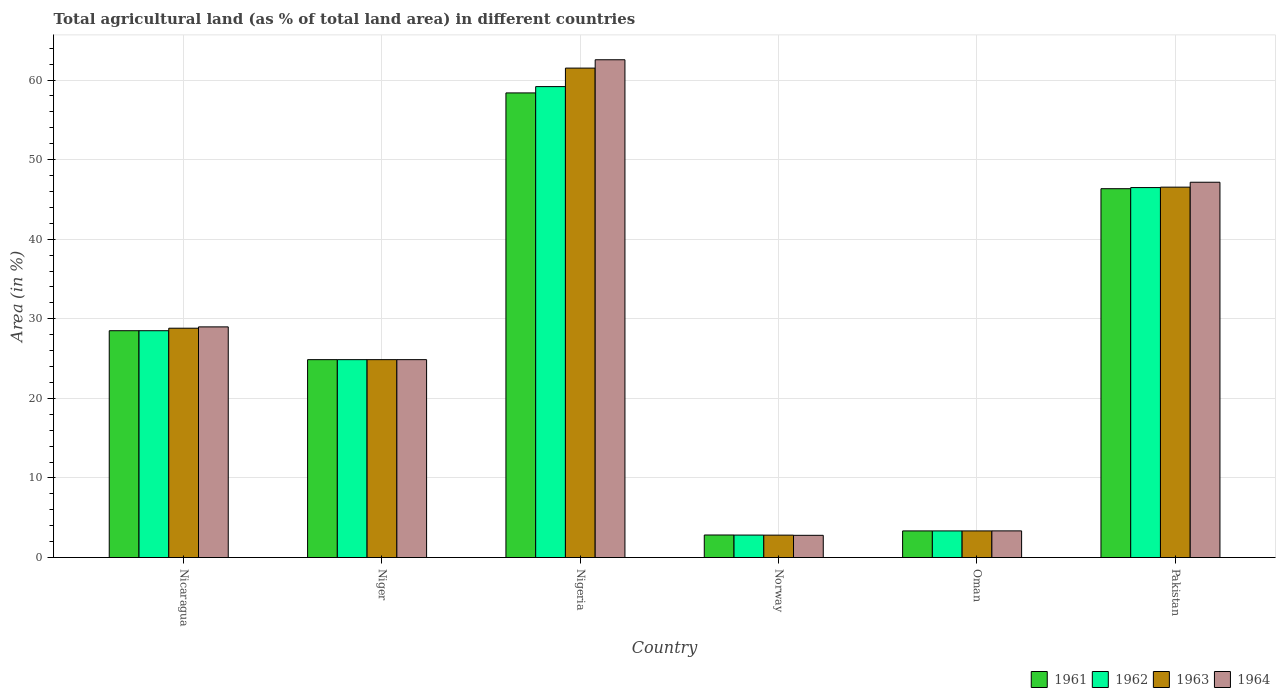How many different coloured bars are there?
Your response must be concise. 4. How many groups of bars are there?
Ensure brevity in your answer.  6. Are the number of bars per tick equal to the number of legend labels?
Your answer should be very brief. Yes. What is the label of the 5th group of bars from the left?
Your answer should be compact. Oman. In how many cases, is the number of bars for a given country not equal to the number of legend labels?
Provide a succinct answer. 0. What is the percentage of agricultural land in 1961 in Niger?
Make the answer very short. 24.87. Across all countries, what is the maximum percentage of agricultural land in 1963?
Give a very brief answer. 61.51. Across all countries, what is the minimum percentage of agricultural land in 1963?
Your answer should be very brief. 2.81. In which country was the percentage of agricultural land in 1963 maximum?
Give a very brief answer. Nigeria. What is the total percentage of agricultural land in 1963 in the graph?
Make the answer very short. 167.89. What is the difference between the percentage of agricultural land in 1962 in Nicaragua and that in Nigeria?
Make the answer very short. -30.68. What is the difference between the percentage of agricultural land in 1964 in Nigeria and the percentage of agricultural land in 1961 in Norway?
Ensure brevity in your answer.  59.72. What is the average percentage of agricultural land in 1962 per country?
Ensure brevity in your answer.  27.54. What is the difference between the percentage of agricultural land of/in 1964 and percentage of agricultural land of/in 1962 in Nicaragua?
Offer a terse response. 0.48. In how many countries, is the percentage of agricultural land in 1963 greater than 24 %?
Your response must be concise. 4. What is the ratio of the percentage of agricultural land in 1963 in Nicaragua to that in Nigeria?
Provide a short and direct response. 0.47. Is the percentage of agricultural land in 1964 in Norway less than that in Pakistan?
Your answer should be compact. Yes. What is the difference between the highest and the second highest percentage of agricultural land in 1963?
Your response must be concise. -32.69. What is the difference between the highest and the lowest percentage of agricultural land in 1963?
Your answer should be compact. 58.69. In how many countries, is the percentage of agricultural land in 1961 greater than the average percentage of agricultural land in 1961 taken over all countries?
Keep it short and to the point. 3. What does the 4th bar from the left in Oman represents?
Ensure brevity in your answer.  1964. Is it the case that in every country, the sum of the percentage of agricultural land in 1962 and percentage of agricultural land in 1961 is greater than the percentage of agricultural land in 1964?
Provide a short and direct response. Yes. How many countries are there in the graph?
Ensure brevity in your answer.  6. Are the values on the major ticks of Y-axis written in scientific E-notation?
Your answer should be compact. No. Does the graph contain any zero values?
Give a very brief answer. No. How many legend labels are there?
Your answer should be very brief. 4. What is the title of the graph?
Your response must be concise. Total agricultural land (as % of total land area) in different countries. What is the label or title of the Y-axis?
Your answer should be very brief. Area (in %). What is the Area (in %) in 1961 in Nicaragua?
Offer a very short reply. 28.5. What is the Area (in %) in 1962 in Nicaragua?
Provide a succinct answer. 28.5. What is the Area (in %) of 1963 in Nicaragua?
Your answer should be compact. 28.82. What is the Area (in %) in 1964 in Nicaragua?
Provide a short and direct response. 28.98. What is the Area (in %) of 1961 in Niger?
Offer a terse response. 24.87. What is the Area (in %) of 1962 in Niger?
Offer a very short reply. 24.87. What is the Area (in %) in 1963 in Niger?
Keep it short and to the point. 24.87. What is the Area (in %) of 1964 in Niger?
Offer a terse response. 24.87. What is the Area (in %) in 1961 in Nigeria?
Provide a succinct answer. 58.39. What is the Area (in %) in 1962 in Nigeria?
Make the answer very short. 59.18. What is the Area (in %) of 1963 in Nigeria?
Your response must be concise. 61.51. What is the Area (in %) of 1964 in Nigeria?
Offer a very short reply. 62.55. What is the Area (in %) of 1961 in Norway?
Make the answer very short. 2.83. What is the Area (in %) in 1962 in Norway?
Your answer should be compact. 2.82. What is the Area (in %) of 1963 in Norway?
Provide a succinct answer. 2.81. What is the Area (in %) of 1964 in Norway?
Provide a succinct answer. 2.79. What is the Area (in %) in 1961 in Oman?
Your response must be concise. 3.34. What is the Area (in %) of 1962 in Oman?
Ensure brevity in your answer.  3.34. What is the Area (in %) of 1963 in Oman?
Give a very brief answer. 3.34. What is the Area (in %) in 1964 in Oman?
Your answer should be very brief. 3.35. What is the Area (in %) in 1961 in Pakistan?
Provide a short and direct response. 46.35. What is the Area (in %) of 1962 in Pakistan?
Ensure brevity in your answer.  46.49. What is the Area (in %) of 1963 in Pakistan?
Keep it short and to the point. 46.54. What is the Area (in %) of 1964 in Pakistan?
Make the answer very short. 47.16. Across all countries, what is the maximum Area (in %) in 1961?
Offer a terse response. 58.39. Across all countries, what is the maximum Area (in %) of 1962?
Give a very brief answer. 59.18. Across all countries, what is the maximum Area (in %) in 1963?
Provide a succinct answer. 61.51. Across all countries, what is the maximum Area (in %) in 1964?
Your response must be concise. 62.55. Across all countries, what is the minimum Area (in %) in 1961?
Keep it short and to the point. 2.83. Across all countries, what is the minimum Area (in %) of 1962?
Your response must be concise. 2.82. Across all countries, what is the minimum Area (in %) in 1963?
Give a very brief answer. 2.81. Across all countries, what is the minimum Area (in %) of 1964?
Give a very brief answer. 2.79. What is the total Area (in %) in 1961 in the graph?
Your answer should be very brief. 164.28. What is the total Area (in %) in 1962 in the graph?
Provide a short and direct response. 165.21. What is the total Area (in %) of 1963 in the graph?
Your response must be concise. 167.89. What is the total Area (in %) of 1964 in the graph?
Your response must be concise. 169.7. What is the difference between the Area (in %) in 1961 in Nicaragua and that in Niger?
Provide a short and direct response. 3.63. What is the difference between the Area (in %) of 1962 in Nicaragua and that in Niger?
Keep it short and to the point. 3.63. What is the difference between the Area (in %) of 1963 in Nicaragua and that in Niger?
Your answer should be compact. 3.95. What is the difference between the Area (in %) in 1964 in Nicaragua and that in Niger?
Keep it short and to the point. 4.12. What is the difference between the Area (in %) of 1961 in Nicaragua and that in Nigeria?
Provide a short and direct response. -29.88. What is the difference between the Area (in %) in 1962 in Nicaragua and that in Nigeria?
Provide a short and direct response. -30.68. What is the difference between the Area (in %) in 1963 in Nicaragua and that in Nigeria?
Offer a very short reply. -32.69. What is the difference between the Area (in %) of 1964 in Nicaragua and that in Nigeria?
Make the answer very short. -33.57. What is the difference between the Area (in %) in 1961 in Nicaragua and that in Norway?
Ensure brevity in your answer.  25.67. What is the difference between the Area (in %) in 1962 in Nicaragua and that in Norway?
Your answer should be very brief. 25.68. What is the difference between the Area (in %) in 1963 in Nicaragua and that in Norway?
Your response must be concise. 26. What is the difference between the Area (in %) in 1964 in Nicaragua and that in Norway?
Offer a terse response. 26.19. What is the difference between the Area (in %) of 1961 in Nicaragua and that in Oman?
Your answer should be very brief. 25.16. What is the difference between the Area (in %) in 1962 in Nicaragua and that in Oman?
Keep it short and to the point. 25.16. What is the difference between the Area (in %) in 1963 in Nicaragua and that in Oman?
Offer a very short reply. 25.47. What is the difference between the Area (in %) of 1964 in Nicaragua and that in Oman?
Your answer should be very brief. 25.64. What is the difference between the Area (in %) of 1961 in Nicaragua and that in Pakistan?
Give a very brief answer. -17.85. What is the difference between the Area (in %) in 1962 in Nicaragua and that in Pakistan?
Keep it short and to the point. -17.99. What is the difference between the Area (in %) in 1963 in Nicaragua and that in Pakistan?
Provide a succinct answer. -17.73. What is the difference between the Area (in %) in 1964 in Nicaragua and that in Pakistan?
Offer a terse response. -18.18. What is the difference between the Area (in %) in 1961 in Niger and that in Nigeria?
Your answer should be compact. -33.52. What is the difference between the Area (in %) in 1962 in Niger and that in Nigeria?
Offer a terse response. -34.31. What is the difference between the Area (in %) in 1963 in Niger and that in Nigeria?
Your answer should be very brief. -36.64. What is the difference between the Area (in %) in 1964 in Niger and that in Nigeria?
Make the answer very short. -37.68. What is the difference between the Area (in %) in 1961 in Niger and that in Norway?
Ensure brevity in your answer.  22.04. What is the difference between the Area (in %) of 1962 in Niger and that in Norway?
Ensure brevity in your answer.  22.05. What is the difference between the Area (in %) in 1963 in Niger and that in Norway?
Give a very brief answer. 22.05. What is the difference between the Area (in %) of 1964 in Niger and that in Norway?
Offer a very short reply. 22.08. What is the difference between the Area (in %) in 1961 in Niger and that in Oman?
Your answer should be compact. 21.52. What is the difference between the Area (in %) of 1962 in Niger and that in Oman?
Your response must be concise. 21.52. What is the difference between the Area (in %) in 1963 in Niger and that in Oman?
Provide a succinct answer. 21.52. What is the difference between the Area (in %) in 1964 in Niger and that in Oman?
Your response must be concise. 21.52. What is the difference between the Area (in %) in 1961 in Niger and that in Pakistan?
Make the answer very short. -21.48. What is the difference between the Area (in %) of 1962 in Niger and that in Pakistan?
Give a very brief answer. -21.62. What is the difference between the Area (in %) of 1963 in Niger and that in Pakistan?
Offer a very short reply. -21.68. What is the difference between the Area (in %) of 1964 in Niger and that in Pakistan?
Give a very brief answer. -22.29. What is the difference between the Area (in %) in 1961 in Nigeria and that in Norway?
Offer a very short reply. 55.56. What is the difference between the Area (in %) of 1962 in Nigeria and that in Norway?
Provide a short and direct response. 56.36. What is the difference between the Area (in %) of 1963 in Nigeria and that in Norway?
Keep it short and to the point. 58.69. What is the difference between the Area (in %) in 1964 in Nigeria and that in Norway?
Your answer should be compact. 59.76. What is the difference between the Area (in %) in 1961 in Nigeria and that in Oman?
Give a very brief answer. 55.04. What is the difference between the Area (in %) of 1962 in Nigeria and that in Oman?
Offer a very short reply. 55.84. What is the difference between the Area (in %) of 1963 in Nigeria and that in Oman?
Your answer should be compact. 58.16. What is the difference between the Area (in %) of 1964 in Nigeria and that in Oman?
Your answer should be compact. 59.21. What is the difference between the Area (in %) in 1961 in Nigeria and that in Pakistan?
Keep it short and to the point. 12.04. What is the difference between the Area (in %) in 1962 in Nigeria and that in Pakistan?
Your answer should be compact. 12.69. What is the difference between the Area (in %) of 1963 in Nigeria and that in Pakistan?
Your answer should be very brief. 14.96. What is the difference between the Area (in %) in 1964 in Nigeria and that in Pakistan?
Provide a short and direct response. 15.39. What is the difference between the Area (in %) of 1961 in Norway and that in Oman?
Offer a terse response. -0.51. What is the difference between the Area (in %) of 1962 in Norway and that in Oman?
Ensure brevity in your answer.  -0.52. What is the difference between the Area (in %) of 1963 in Norway and that in Oman?
Make the answer very short. -0.53. What is the difference between the Area (in %) in 1964 in Norway and that in Oman?
Your answer should be compact. -0.56. What is the difference between the Area (in %) of 1961 in Norway and that in Pakistan?
Provide a succinct answer. -43.52. What is the difference between the Area (in %) of 1962 in Norway and that in Pakistan?
Offer a terse response. -43.67. What is the difference between the Area (in %) of 1963 in Norway and that in Pakistan?
Ensure brevity in your answer.  -43.73. What is the difference between the Area (in %) of 1964 in Norway and that in Pakistan?
Your response must be concise. -44.37. What is the difference between the Area (in %) in 1961 in Oman and that in Pakistan?
Make the answer very short. -43.01. What is the difference between the Area (in %) of 1962 in Oman and that in Pakistan?
Give a very brief answer. -43.15. What is the difference between the Area (in %) in 1963 in Oman and that in Pakistan?
Make the answer very short. -43.2. What is the difference between the Area (in %) in 1964 in Oman and that in Pakistan?
Offer a very short reply. -43.81. What is the difference between the Area (in %) of 1961 in Nicaragua and the Area (in %) of 1962 in Niger?
Offer a terse response. 3.63. What is the difference between the Area (in %) of 1961 in Nicaragua and the Area (in %) of 1963 in Niger?
Give a very brief answer. 3.63. What is the difference between the Area (in %) in 1961 in Nicaragua and the Area (in %) in 1964 in Niger?
Provide a succinct answer. 3.63. What is the difference between the Area (in %) of 1962 in Nicaragua and the Area (in %) of 1963 in Niger?
Your response must be concise. 3.63. What is the difference between the Area (in %) of 1962 in Nicaragua and the Area (in %) of 1964 in Niger?
Give a very brief answer. 3.63. What is the difference between the Area (in %) of 1963 in Nicaragua and the Area (in %) of 1964 in Niger?
Offer a terse response. 3.95. What is the difference between the Area (in %) of 1961 in Nicaragua and the Area (in %) of 1962 in Nigeria?
Ensure brevity in your answer.  -30.68. What is the difference between the Area (in %) of 1961 in Nicaragua and the Area (in %) of 1963 in Nigeria?
Make the answer very short. -33. What is the difference between the Area (in %) of 1961 in Nicaragua and the Area (in %) of 1964 in Nigeria?
Keep it short and to the point. -34.05. What is the difference between the Area (in %) of 1962 in Nicaragua and the Area (in %) of 1963 in Nigeria?
Your response must be concise. -33. What is the difference between the Area (in %) in 1962 in Nicaragua and the Area (in %) in 1964 in Nigeria?
Give a very brief answer. -34.05. What is the difference between the Area (in %) of 1963 in Nicaragua and the Area (in %) of 1964 in Nigeria?
Ensure brevity in your answer.  -33.73. What is the difference between the Area (in %) in 1961 in Nicaragua and the Area (in %) in 1962 in Norway?
Offer a very short reply. 25.68. What is the difference between the Area (in %) of 1961 in Nicaragua and the Area (in %) of 1963 in Norway?
Offer a very short reply. 25.69. What is the difference between the Area (in %) in 1961 in Nicaragua and the Area (in %) in 1964 in Norway?
Offer a very short reply. 25.71. What is the difference between the Area (in %) of 1962 in Nicaragua and the Area (in %) of 1963 in Norway?
Offer a terse response. 25.69. What is the difference between the Area (in %) in 1962 in Nicaragua and the Area (in %) in 1964 in Norway?
Offer a terse response. 25.71. What is the difference between the Area (in %) in 1963 in Nicaragua and the Area (in %) in 1964 in Norway?
Give a very brief answer. 26.03. What is the difference between the Area (in %) of 1961 in Nicaragua and the Area (in %) of 1962 in Oman?
Offer a very short reply. 25.16. What is the difference between the Area (in %) in 1961 in Nicaragua and the Area (in %) in 1963 in Oman?
Keep it short and to the point. 25.16. What is the difference between the Area (in %) of 1961 in Nicaragua and the Area (in %) of 1964 in Oman?
Ensure brevity in your answer.  25.16. What is the difference between the Area (in %) of 1962 in Nicaragua and the Area (in %) of 1963 in Oman?
Provide a short and direct response. 25.16. What is the difference between the Area (in %) of 1962 in Nicaragua and the Area (in %) of 1964 in Oman?
Your answer should be compact. 25.16. What is the difference between the Area (in %) in 1963 in Nicaragua and the Area (in %) in 1964 in Oman?
Give a very brief answer. 25.47. What is the difference between the Area (in %) of 1961 in Nicaragua and the Area (in %) of 1962 in Pakistan?
Make the answer very short. -17.99. What is the difference between the Area (in %) in 1961 in Nicaragua and the Area (in %) in 1963 in Pakistan?
Ensure brevity in your answer.  -18.04. What is the difference between the Area (in %) of 1961 in Nicaragua and the Area (in %) of 1964 in Pakistan?
Offer a very short reply. -18.66. What is the difference between the Area (in %) of 1962 in Nicaragua and the Area (in %) of 1963 in Pakistan?
Make the answer very short. -18.04. What is the difference between the Area (in %) of 1962 in Nicaragua and the Area (in %) of 1964 in Pakistan?
Keep it short and to the point. -18.66. What is the difference between the Area (in %) in 1963 in Nicaragua and the Area (in %) in 1964 in Pakistan?
Your answer should be compact. -18.34. What is the difference between the Area (in %) in 1961 in Niger and the Area (in %) in 1962 in Nigeria?
Offer a terse response. -34.31. What is the difference between the Area (in %) in 1961 in Niger and the Area (in %) in 1963 in Nigeria?
Offer a very short reply. -36.64. What is the difference between the Area (in %) in 1961 in Niger and the Area (in %) in 1964 in Nigeria?
Ensure brevity in your answer.  -37.68. What is the difference between the Area (in %) in 1962 in Niger and the Area (in %) in 1963 in Nigeria?
Offer a terse response. -36.64. What is the difference between the Area (in %) of 1962 in Niger and the Area (in %) of 1964 in Nigeria?
Ensure brevity in your answer.  -37.68. What is the difference between the Area (in %) in 1963 in Niger and the Area (in %) in 1964 in Nigeria?
Offer a terse response. -37.68. What is the difference between the Area (in %) of 1961 in Niger and the Area (in %) of 1962 in Norway?
Offer a terse response. 22.05. What is the difference between the Area (in %) in 1961 in Niger and the Area (in %) in 1963 in Norway?
Provide a succinct answer. 22.05. What is the difference between the Area (in %) of 1961 in Niger and the Area (in %) of 1964 in Norway?
Give a very brief answer. 22.08. What is the difference between the Area (in %) in 1962 in Niger and the Area (in %) in 1963 in Norway?
Your answer should be compact. 22.05. What is the difference between the Area (in %) of 1962 in Niger and the Area (in %) of 1964 in Norway?
Offer a very short reply. 22.08. What is the difference between the Area (in %) in 1963 in Niger and the Area (in %) in 1964 in Norway?
Keep it short and to the point. 22.08. What is the difference between the Area (in %) in 1961 in Niger and the Area (in %) in 1962 in Oman?
Ensure brevity in your answer.  21.52. What is the difference between the Area (in %) in 1961 in Niger and the Area (in %) in 1963 in Oman?
Make the answer very short. 21.52. What is the difference between the Area (in %) of 1961 in Niger and the Area (in %) of 1964 in Oman?
Provide a succinct answer. 21.52. What is the difference between the Area (in %) in 1962 in Niger and the Area (in %) in 1963 in Oman?
Provide a short and direct response. 21.52. What is the difference between the Area (in %) in 1962 in Niger and the Area (in %) in 1964 in Oman?
Your answer should be very brief. 21.52. What is the difference between the Area (in %) of 1963 in Niger and the Area (in %) of 1964 in Oman?
Your answer should be very brief. 21.52. What is the difference between the Area (in %) in 1961 in Niger and the Area (in %) in 1962 in Pakistan?
Your response must be concise. -21.62. What is the difference between the Area (in %) of 1961 in Niger and the Area (in %) of 1963 in Pakistan?
Keep it short and to the point. -21.68. What is the difference between the Area (in %) of 1961 in Niger and the Area (in %) of 1964 in Pakistan?
Your response must be concise. -22.29. What is the difference between the Area (in %) in 1962 in Niger and the Area (in %) in 1963 in Pakistan?
Offer a terse response. -21.68. What is the difference between the Area (in %) in 1962 in Niger and the Area (in %) in 1964 in Pakistan?
Ensure brevity in your answer.  -22.29. What is the difference between the Area (in %) of 1963 in Niger and the Area (in %) of 1964 in Pakistan?
Your answer should be very brief. -22.29. What is the difference between the Area (in %) in 1961 in Nigeria and the Area (in %) in 1962 in Norway?
Give a very brief answer. 55.56. What is the difference between the Area (in %) in 1961 in Nigeria and the Area (in %) in 1963 in Norway?
Give a very brief answer. 55.57. What is the difference between the Area (in %) in 1961 in Nigeria and the Area (in %) in 1964 in Norway?
Your response must be concise. 55.6. What is the difference between the Area (in %) in 1962 in Nigeria and the Area (in %) in 1963 in Norway?
Give a very brief answer. 56.37. What is the difference between the Area (in %) in 1962 in Nigeria and the Area (in %) in 1964 in Norway?
Your answer should be very brief. 56.39. What is the difference between the Area (in %) of 1963 in Nigeria and the Area (in %) of 1964 in Norway?
Offer a terse response. 58.72. What is the difference between the Area (in %) in 1961 in Nigeria and the Area (in %) in 1962 in Oman?
Make the answer very short. 55.04. What is the difference between the Area (in %) of 1961 in Nigeria and the Area (in %) of 1963 in Oman?
Ensure brevity in your answer.  55.04. What is the difference between the Area (in %) in 1961 in Nigeria and the Area (in %) in 1964 in Oman?
Your answer should be very brief. 55.04. What is the difference between the Area (in %) of 1962 in Nigeria and the Area (in %) of 1963 in Oman?
Your response must be concise. 55.84. What is the difference between the Area (in %) in 1962 in Nigeria and the Area (in %) in 1964 in Oman?
Offer a terse response. 55.83. What is the difference between the Area (in %) in 1963 in Nigeria and the Area (in %) in 1964 in Oman?
Offer a very short reply. 58.16. What is the difference between the Area (in %) in 1961 in Nigeria and the Area (in %) in 1962 in Pakistan?
Offer a very short reply. 11.89. What is the difference between the Area (in %) in 1961 in Nigeria and the Area (in %) in 1963 in Pakistan?
Your response must be concise. 11.84. What is the difference between the Area (in %) in 1961 in Nigeria and the Area (in %) in 1964 in Pakistan?
Keep it short and to the point. 11.23. What is the difference between the Area (in %) of 1962 in Nigeria and the Area (in %) of 1963 in Pakistan?
Ensure brevity in your answer.  12.64. What is the difference between the Area (in %) of 1962 in Nigeria and the Area (in %) of 1964 in Pakistan?
Offer a very short reply. 12.02. What is the difference between the Area (in %) in 1963 in Nigeria and the Area (in %) in 1964 in Pakistan?
Offer a very short reply. 14.34. What is the difference between the Area (in %) in 1961 in Norway and the Area (in %) in 1962 in Oman?
Your answer should be very brief. -0.51. What is the difference between the Area (in %) in 1961 in Norway and the Area (in %) in 1963 in Oman?
Provide a short and direct response. -0.51. What is the difference between the Area (in %) in 1961 in Norway and the Area (in %) in 1964 in Oman?
Offer a very short reply. -0.52. What is the difference between the Area (in %) in 1962 in Norway and the Area (in %) in 1963 in Oman?
Give a very brief answer. -0.52. What is the difference between the Area (in %) in 1962 in Norway and the Area (in %) in 1964 in Oman?
Provide a short and direct response. -0.52. What is the difference between the Area (in %) in 1963 in Norway and the Area (in %) in 1964 in Oman?
Your answer should be very brief. -0.53. What is the difference between the Area (in %) in 1961 in Norway and the Area (in %) in 1962 in Pakistan?
Keep it short and to the point. -43.66. What is the difference between the Area (in %) of 1961 in Norway and the Area (in %) of 1963 in Pakistan?
Offer a terse response. -43.71. What is the difference between the Area (in %) in 1961 in Norway and the Area (in %) in 1964 in Pakistan?
Offer a very short reply. -44.33. What is the difference between the Area (in %) of 1962 in Norway and the Area (in %) of 1963 in Pakistan?
Provide a succinct answer. -43.72. What is the difference between the Area (in %) in 1962 in Norway and the Area (in %) in 1964 in Pakistan?
Make the answer very short. -44.34. What is the difference between the Area (in %) in 1963 in Norway and the Area (in %) in 1964 in Pakistan?
Your response must be concise. -44.35. What is the difference between the Area (in %) in 1961 in Oman and the Area (in %) in 1962 in Pakistan?
Your answer should be compact. -43.15. What is the difference between the Area (in %) in 1961 in Oman and the Area (in %) in 1963 in Pakistan?
Provide a short and direct response. -43.2. What is the difference between the Area (in %) of 1961 in Oman and the Area (in %) of 1964 in Pakistan?
Make the answer very short. -43.82. What is the difference between the Area (in %) in 1962 in Oman and the Area (in %) in 1963 in Pakistan?
Make the answer very short. -43.2. What is the difference between the Area (in %) in 1962 in Oman and the Area (in %) in 1964 in Pakistan?
Offer a very short reply. -43.82. What is the difference between the Area (in %) in 1963 in Oman and the Area (in %) in 1964 in Pakistan?
Your answer should be very brief. -43.82. What is the average Area (in %) in 1961 per country?
Your response must be concise. 27.38. What is the average Area (in %) of 1962 per country?
Offer a very short reply. 27.54. What is the average Area (in %) of 1963 per country?
Offer a very short reply. 27.98. What is the average Area (in %) of 1964 per country?
Give a very brief answer. 28.28. What is the difference between the Area (in %) of 1961 and Area (in %) of 1963 in Nicaragua?
Give a very brief answer. -0.32. What is the difference between the Area (in %) in 1961 and Area (in %) in 1964 in Nicaragua?
Your answer should be very brief. -0.48. What is the difference between the Area (in %) of 1962 and Area (in %) of 1963 in Nicaragua?
Your answer should be compact. -0.32. What is the difference between the Area (in %) of 1962 and Area (in %) of 1964 in Nicaragua?
Offer a very short reply. -0.48. What is the difference between the Area (in %) in 1963 and Area (in %) in 1964 in Nicaragua?
Provide a succinct answer. -0.17. What is the difference between the Area (in %) of 1961 and Area (in %) of 1963 in Niger?
Your response must be concise. 0. What is the difference between the Area (in %) of 1962 and Area (in %) of 1963 in Niger?
Make the answer very short. 0. What is the difference between the Area (in %) of 1962 and Area (in %) of 1964 in Niger?
Your answer should be compact. 0. What is the difference between the Area (in %) of 1961 and Area (in %) of 1962 in Nigeria?
Provide a short and direct response. -0.79. What is the difference between the Area (in %) in 1961 and Area (in %) in 1963 in Nigeria?
Ensure brevity in your answer.  -3.12. What is the difference between the Area (in %) in 1961 and Area (in %) in 1964 in Nigeria?
Offer a very short reply. -4.17. What is the difference between the Area (in %) of 1962 and Area (in %) of 1963 in Nigeria?
Keep it short and to the point. -2.32. What is the difference between the Area (in %) of 1962 and Area (in %) of 1964 in Nigeria?
Provide a short and direct response. -3.37. What is the difference between the Area (in %) of 1963 and Area (in %) of 1964 in Nigeria?
Ensure brevity in your answer.  -1.05. What is the difference between the Area (in %) in 1961 and Area (in %) in 1962 in Norway?
Provide a succinct answer. 0.01. What is the difference between the Area (in %) of 1961 and Area (in %) of 1963 in Norway?
Your response must be concise. 0.02. What is the difference between the Area (in %) of 1961 and Area (in %) of 1964 in Norway?
Offer a very short reply. 0.04. What is the difference between the Area (in %) in 1962 and Area (in %) in 1963 in Norway?
Provide a succinct answer. 0.01. What is the difference between the Area (in %) in 1962 and Area (in %) in 1964 in Norway?
Provide a succinct answer. 0.03. What is the difference between the Area (in %) in 1963 and Area (in %) in 1964 in Norway?
Give a very brief answer. 0.02. What is the difference between the Area (in %) of 1961 and Area (in %) of 1962 in Oman?
Provide a succinct answer. 0. What is the difference between the Area (in %) in 1961 and Area (in %) in 1964 in Oman?
Offer a very short reply. -0. What is the difference between the Area (in %) in 1962 and Area (in %) in 1964 in Oman?
Offer a very short reply. -0. What is the difference between the Area (in %) of 1963 and Area (in %) of 1964 in Oman?
Offer a terse response. -0. What is the difference between the Area (in %) in 1961 and Area (in %) in 1962 in Pakistan?
Give a very brief answer. -0.14. What is the difference between the Area (in %) in 1961 and Area (in %) in 1963 in Pakistan?
Give a very brief answer. -0.19. What is the difference between the Area (in %) in 1961 and Area (in %) in 1964 in Pakistan?
Keep it short and to the point. -0.81. What is the difference between the Area (in %) of 1962 and Area (in %) of 1963 in Pakistan?
Your response must be concise. -0.05. What is the difference between the Area (in %) of 1962 and Area (in %) of 1964 in Pakistan?
Keep it short and to the point. -0.67. What is the difference between the Area (in %) in 1963 and Area (in %) in 1964 in Pakistan?
Ensure brevity in your answer.  -0.62. What is the ratio of the Area (in %) in 1961 in Nicaragua to that in Niger?
Ensure brevity in your answer.  1.15. What is the ratio of the Area (in %) of 1962 in Nicaragua to that in Niger?
Ensure brevity in your answer.  1.15. What is the ratio of the Area (in %) in 1963 in Nicaragua to that in Niger?
Keep it short and to the point. 1.16. What is the ratio of the Area (in %) of 1964 in Nicaragua to that in Niger?
Your answer should be compact. 1.17. What is the ratio of the Area (in %) in 1961 in Nicaragua to that in Nigeria?
Ensure brevity in your answer.  0.49. What is the ratio of the Area (in %) in 1962 in Nicaragua to that in Nigeria?
Provide a succinct answer. 0.48. What is the ratio of the Area (in %) in 1963 in Nicaragua to that in Nigeria?
Offer a very short reply. 0.47. What is the ratio of the Area (in %) in 1964 in Nicaragua to that in Nigeria?
Offer a terse response. 0.46. What is the ratio of the Area (in %) of 1961 in Nicaragua to that in Norway?
Keep it short and to the point. 10.07. What is the ratio of the Area (in %) in 1962 in Nicaragua to that in Norway?
Make the answer very short. 10.1. What is the ratio of the Area (in %) in 1963 in Nicaragua to that in Norway?
Keep it short and to the point. 10.24. What is the ratio of the Area (in %) in 1964 in Nicaragua to that in Norway?
Provide a succinct answer. 10.39. What is the ratio of the Area (in %) of 1961 in Nicaragua to that in Oman?
Your response must be concise. 8.52. What is the ratio of the Area (in %) in 1962 in Nicaragua to that in Oman?
Make the answer very short. 8.52. What is the ratio of the Area (in %) of 1963 in Nicaragua to that in Oman?
Provide a short and direct response. 8.62. What is the ratio of the Area (in %) in 1964 in Nicaragua to that in Oman?
Your answer should be very brief. 8.66. What is the ratio of the Area (in %) in 1961 in Nicaragua to that in Pakistan?
Make the answer very short. 0.61. What is the ratio of the Area (in %) of 1962 in Nicaragua to that in Pakistan?
Make the answer very short. 0.61. What is the ratio of the Area (in %) of 1963 in Nicaragua to that in Pakistan?
Your response must be concise. 0.62. What is the ratio of the Area (in %) in 1964 in Nicaragua to that in Pakistan?
Provide a short and direct response. 0.61. What is the ratio of the Area (in %) of 1961 in Niger to that in Nigeria?
Ensure brevity in your answer.  0.43. What is the ratio of the Area (in %) in 1962 in Niger to that in Nigeria?
Give a very brief answer. 0.42. What is the ratio of the Area (in %) of 1963 in Niger to that in Nigeria?
Offer a very short reply. 0.4. What is the ratio of the Area (in %) in 1964 in Niger to that in Nigeria?
Provide a succinct answer. 0.4. What is the ratio of the Area (in %) in 1961 in Niger to that in Norway?
Provide a succinct answer. 8.78. What is the ratio of the Area (in %) of 1962 in Niger to that in Norway?
Your answer should be compact. 8.81. What is the ratio of the Area (in %) of 1963 in Niger to that in Norway?
Keep it short and to the point. 8.84. What is the ratio of the Area (in %) of 1964 in Niger to that in Norway?
Make the answer very short. 8.91. What is the ratio of the Area (in %) of 1961 in Niger to that in Oman?
Provide a short and direct response. 7.44. What is the ratio of the Area (in %) of 1962 in Niger to that in Oman?
Provide a short and direct response. 7.44. What is the ratio of the Area (in %) of 1963 in Niger to that in Oman?
Your answer should be very brief. 7.44. What is the ratio of the Area (in %) of 1964 in Niger to that in Oman?
Make the answer very short. 7.43. What is the ratio of the Area (in %) of 1961 in Niger to that in Pakistan?
Give a very brief answer. 0.54. What is the ratio of the Area (in %) in 1962 in Niger to that in Pakistan?
Provide a short and direct response. 0.53. What is the ratio of the Area (in %) of 1963 in Niger to that in Pakistan?
Provide a short and direct response. 0.53. What is the ratio of the Area (in %) of 1964 in Niger to that in Pakistan?
Give a very brief answer. 0.53. What is the ratio of the Area (in %) of 1961 in Nigeria to that in Norway?
Make the answer very short. 20.62. What is the ratio of the Area (in %) of 1962 in Nigeria to that in Norway?
Give a very brief answer. 20.97. What is the ratio of the Area (in %) of 1963 in Nigeria to that in Norway?
Keep it short and to the point. 21.85. What is the ratio of the Area (in %) in 1964 in Nigeria to that in Norway?
Make the answer very short. 22.42. What is the ratio of the Area (in %) of 1961 in Nigeria to that in Oman?
Your response must be concise. 17.46. What is the ratio of the Area (in %) in 1962 in Nigeria to that in Oman?
Your answer should be compact. 17.7. What is the ratio of the Area (in %) in 1963 in Nigeria to that in Oman?
Your response must be concise. 18.39. What is the ratio of the Area (in %) in 1964 in Nigeria to that in Oman?
Provide a succinct answer. 18.69. What is the ratio of the Area (in %) of 1961 in Nigeria to that in Pakistan?
Keep it short and to the point. 1.26. What is the ratio of the Area (in %) in 1962 in Nigeria to that in Pakistan?
Your response must be concise. 1.27. What is the ratio of the Area (in %) of 1963 in Nigeria to that in Pakistan?
Ensure brevity in your answer.  1.32. What is the ratio of the Area (in %) in 1964 in Nigeria to that in Pakistan?
Your answer should be compact. 1.33. What is the ratio of the Area (in %) of 1961 in Norway to that in Oman?
Your answer should be very brief. 0.85. What is the ratio of the Area (in %) of 1962 in Norway to that in Oman?
Provide a succinct answer. 0.84. What is the ratio of the Area (in %) of 1963 in Norway to that in Oman?
Offer a very short reply. 0.84. What is the ratio of the Area (in %) of 1964 in Norway to that in Oman?
Provide a short and direct response. 0.83. What is the ratio of the Area (in %) in 1961 in Norway to that in Pakistan?
Give a very brief answer. 0.06. What is the ratio of the Area (in %) in 1962 in Norway to that in Pakistan?
Provide a short and direct response. 0.06. What is the ratio of the Area (in %) in 1963 in Norway to that in Pakistan?
Make the answer very short. 0.06. What is the ratio of the Area (in %) in 1964 in Norway to that in Pakistan?
Provide a succinct answer. 0.06. What is the ratio of the Area (in %) of 1961 in Oman to that in Pakistan?
Provide a succinct answer. 0.07. What is the ratio of the Area (in %) of 1962 in Oman to that in Pakistan?
Give a very brief answer. 0.07. What is the ratio of the Area (in %) in 1963 in Oman to that in Pakistan?
Provide a short and direct response. 0.07. What is the ratio of the Area (in %) in 1964 in Oman to that in Pakistan?
Make the answer very short. 0.07. What is the difference between the highest and the second highest Area (in %) of 1961?
Your answer should be compact. 12.04. What is the difference between the highest and the second highest Area (in %) in 1962?
Give a very brief answer. 12.69. What is the difference between the highest and the second highest Area (in %) of 1963?
Offer a terse response. 14.96. What is the difference between the highest and the second highest Area (in %) of 1964?
Give a very brief answer. 15.39. What is the difference between the highest and the lowest Area (in %) in 1961?
Provide a succinct answer. 55.56. What is the difference between the highest and the lowest Area (in %) of 1962?
Offer a very short reply. 56.36. What is the difference between the highest and the lowest Area (in %) in 1963?
Provide a succinct answer. 58.69. What is the difference between the highest and the lowest Area (in %) of 1964?
Ensure brevity in your answer.  59.76. 